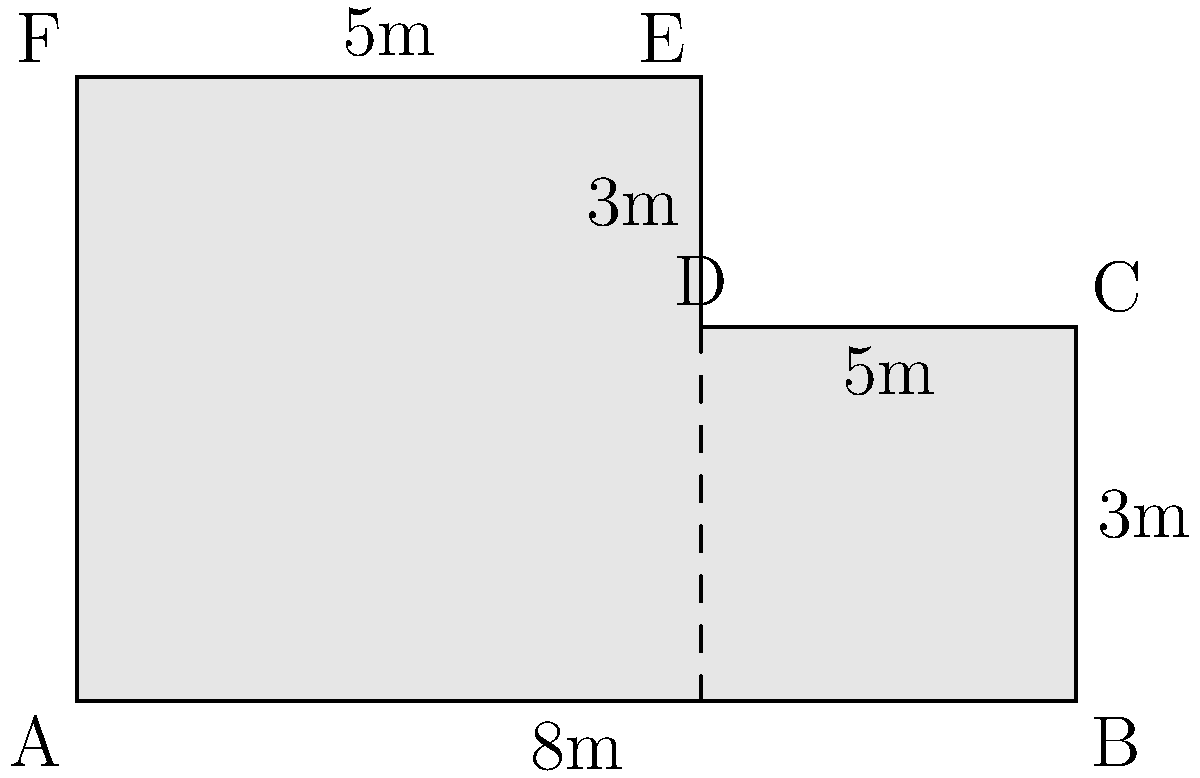As a singer preparing for your next big performance, you've been given the floor plan of an irregularly-shaped concert venue. The venue's shape is represented by the figure above, where all angles are right angles. Calculate the total floor area of the venue in square meters. To find the area of this irregularly-shaped concert venue, we can divide it into two rectangles and calculate their areas separately:

1. Rectangle ABCF:
   Length = 8m, Width = 3m
   Area of ABCF = $8m \times 3m = 24m^2$

2. Rectangle ADEF:
   Length = 5m, Width = 2m (5m - 3m = 2m)
   Area of ADEF = $5m \times 2m = 10m^2$

3. Total area:
   Total area = Area of ABCF + Area of ADEF
   $$ \text{Total area} = 24m^2 + 10m^2 = 34m^2 $$

Therefore, the total floor area of the concert venue is 34 square meters.
Answer: $34m^2$ 